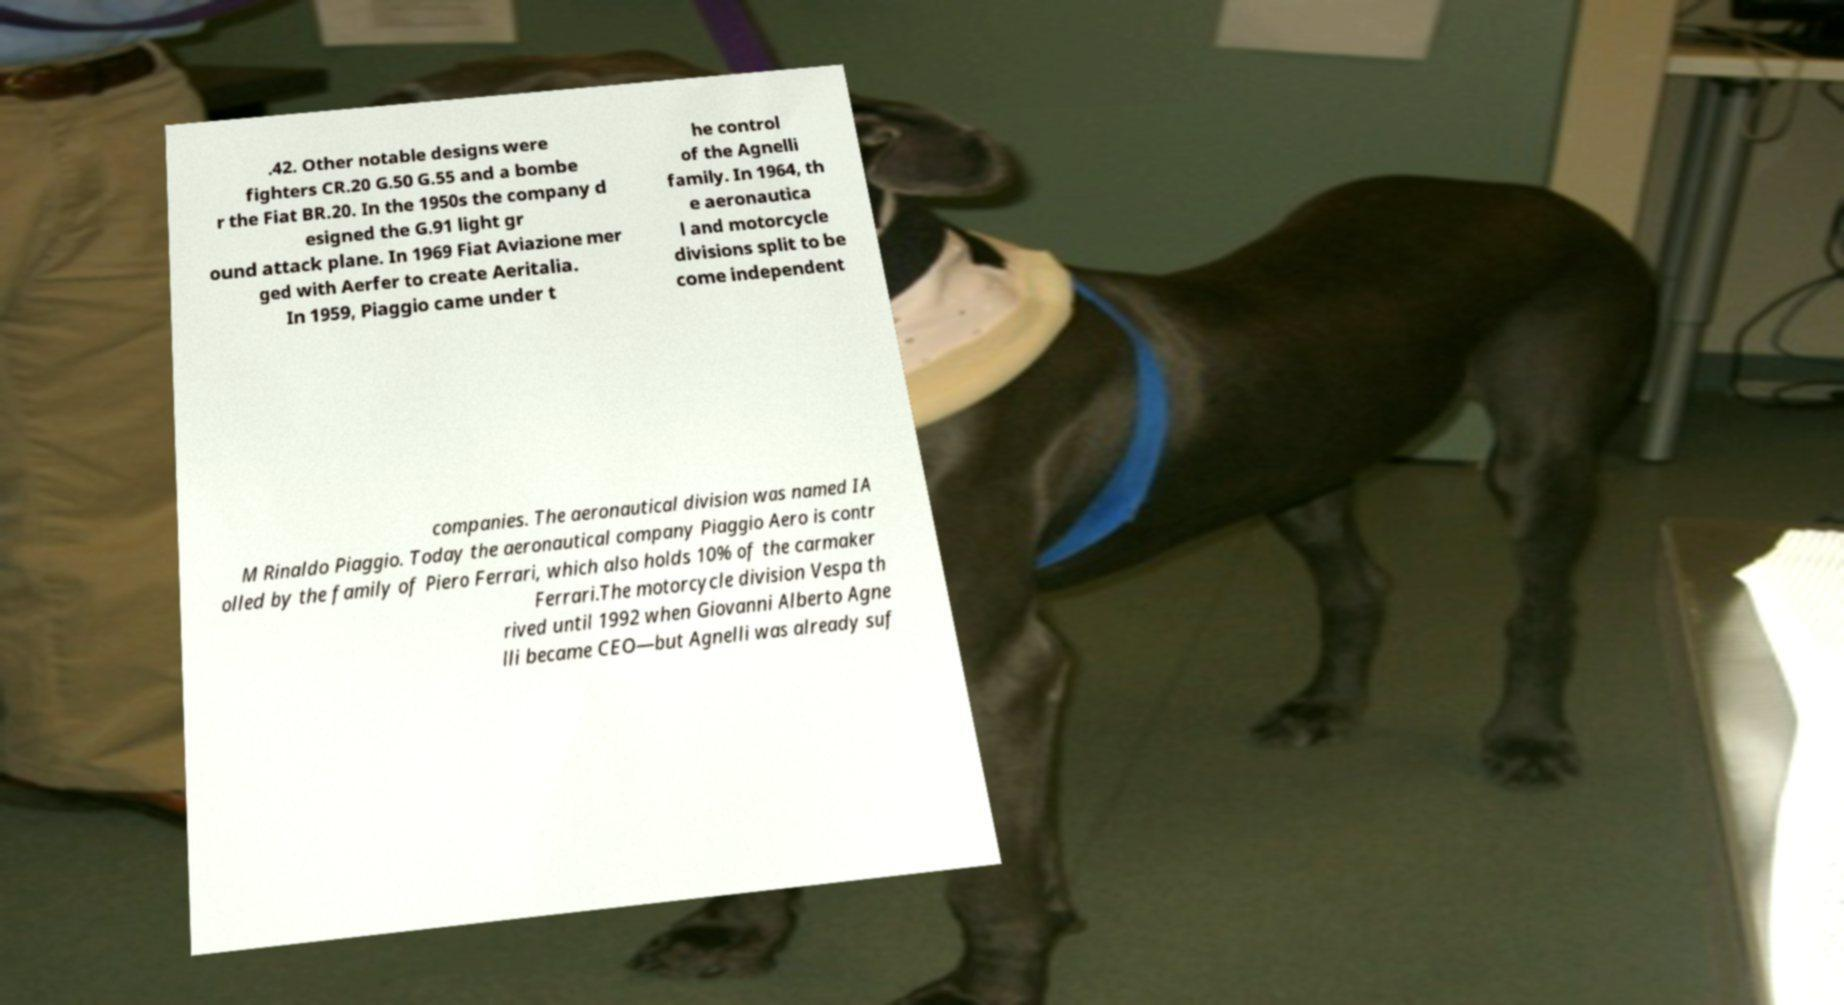Please read and relay the text visible in this image. What does it say? .42. Other notable designs were fighters CR.20 G.50 G.55 and a bombe r the Fiat BR.20. In the 1950s the company d esigned the G.91 light gr ound attack plane. In 1969 Fiat Aviazione mer ged with Aerfer to create Aeritalia. In 1959, Piaggio came under t he control of the Agnelli family. In 1964, th e aeronautica l and motorcycle divisions split to be come independent companies. The aeronautical division was named IA M Rinaldo Piaggio. Today the aeronautical company Piaggio Aero is contr olled by the family of Piero Ferrari, which also holds 10% of the carmaker Ferrari.The motorcycle division Vespa th rived until 1992 when Giovanni Alberto Agne lli became CEO—but Agnelli was already suf 